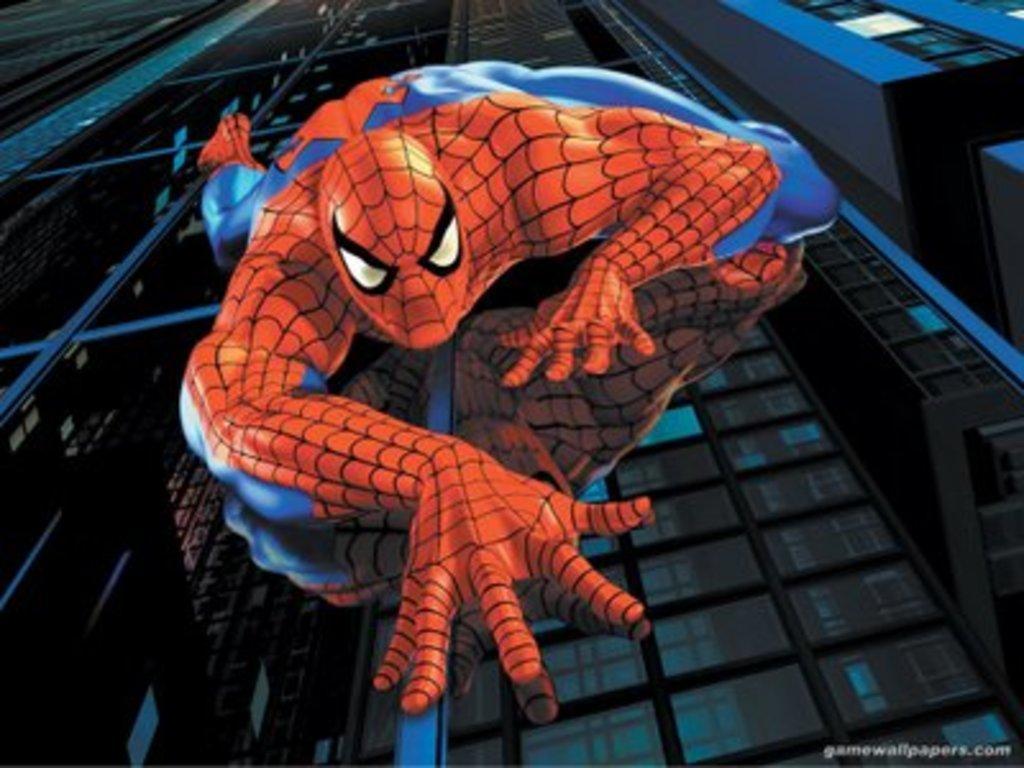Could you give a brief overview of what you see in this image? In the picture I can see a person in the spider man costume and the person is on the glass windows of the building. It is looking like another building on the top right side of the picture. 